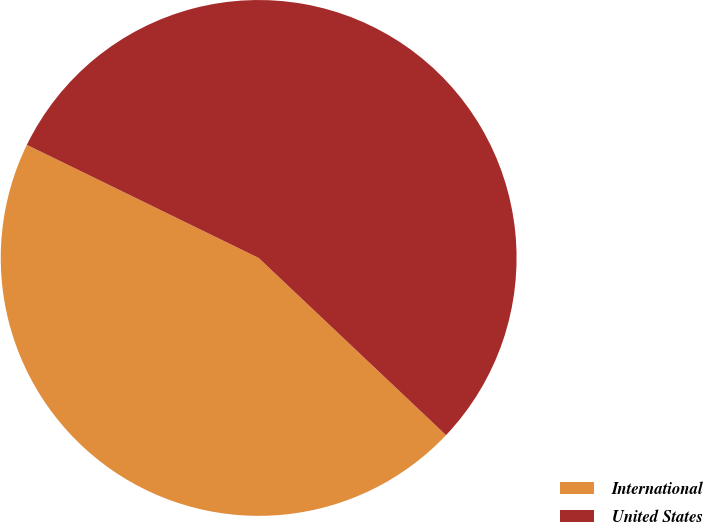Convert chart to OTSL. <chart><loc_0><loc_0><loc_500><loc_500><pie_chart><fcel>International<fcel>United States<nl><fcel>45.17%<fcel>54.83%<nl></chart> 